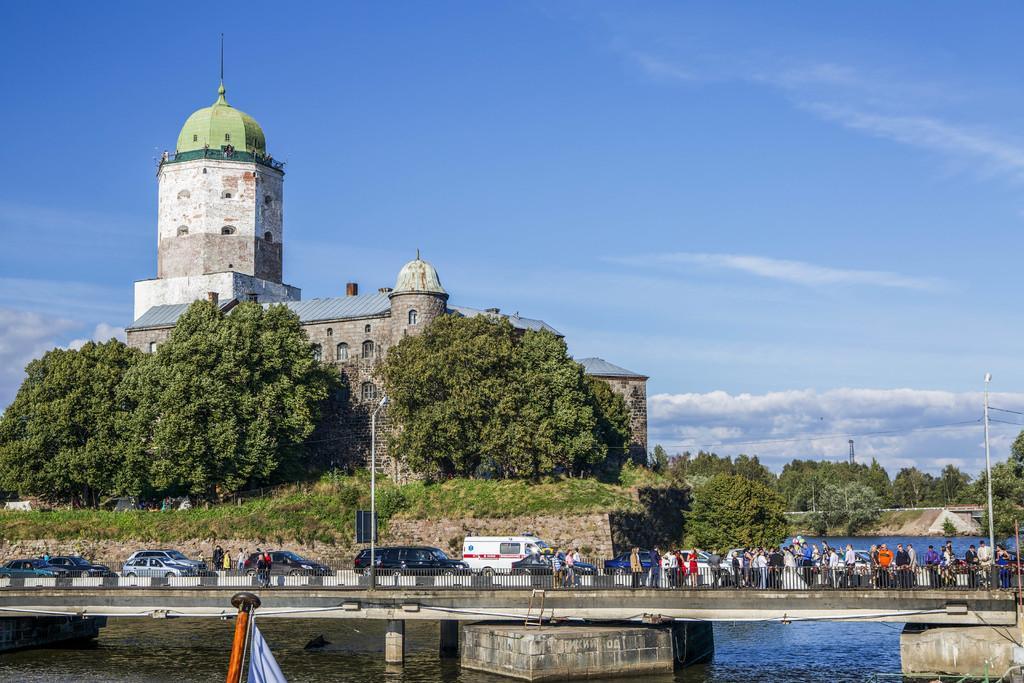Can you describe this image briefly? In the picture we can see a bridge on the water, on the bridge we can see some vehicles and some people standing near the railing and behind the bridge we can see plants and trees and a historical building and near to it also we can see many trees and in the background we can see the sky with clouds. 